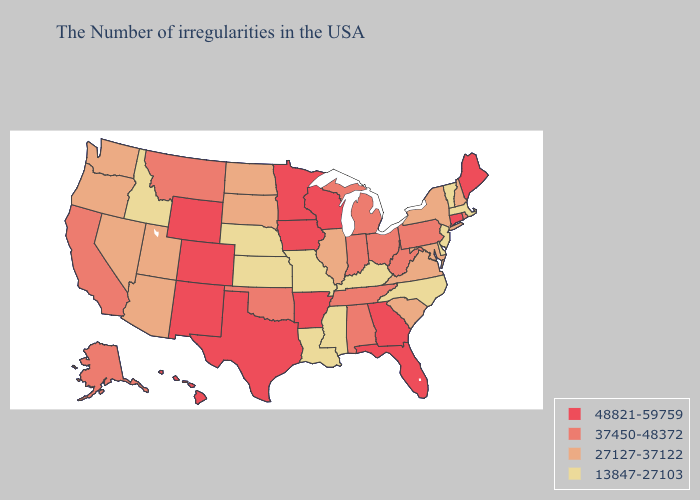What is the lowest value in the USA?
Quick response, please. 13847-27103. Does Vermont have the highest value in the Northeast?
Be succinct. No. Does Arkansas have the highest value in the South?
Answer briefly. Yes. What is the highest value in the USA?
Keep it brief. 48821-59759. How many symbols are there in the legend?
Short answer required. 4. What is the value of Oklahoma?
Quick response, please. 37450-48372. Name the states that have a value in the range 37450-48372?
Short answer required. Rhode Island, Pennsylvania, West Virginia, Ohio, Michigan, Indiana, Alabama, Tennessee, Oklahoma, Montana, California, Alaska. What is the value of Virginia?
Give a very brief answer. 27127-37122. Name the states that have a value in the range 27127-37122?
Keep it brief. New Hampshire, New York, Maryland, Virginia, South Carolina, Illinois, South Dakota, North Dakota, Utah, Arizona, Nevada, Washington, Oregon. What is the highest value in the MidWest ?
Short answer required. 48821-59759. What is the highest value in the MidWest ?
Be succinct. 48821-59759. Does New York have the highest value in the Northeast?
Quick response, please. No. Name the states that have a value in the range 27127-37122?
Short answer required. New Hampshire, New York, Maryland, Virginia, South Carolina, Illinois, South Dakota, North Dakota, Utah, Arizona, Nevada, Washington, Oregon. Which states have the highest value in the USA?
Concise answer only. Maine, Connecticut, Florida, Georgia, Wisconsin, Arkansas, Minnesota, Iowa, Texas, Wyoming, Colorado, New Mexico, Hawaii. Name the states that have a value in the range 27127-37122?
Write a very short answer. New Hampshire, New York, Maryland, Virginia, South Carolina, Illinois, South Dakota, North Dakota, Utah, Arizona, Nevada, Washington, Oregon. 